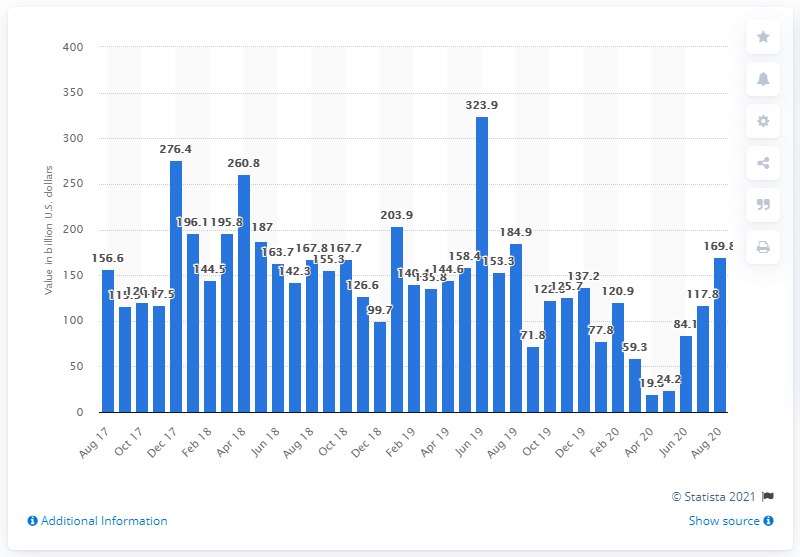Point out several critical features in this image. In August 2020, the value of U.S. M&A deals was 169.8. 